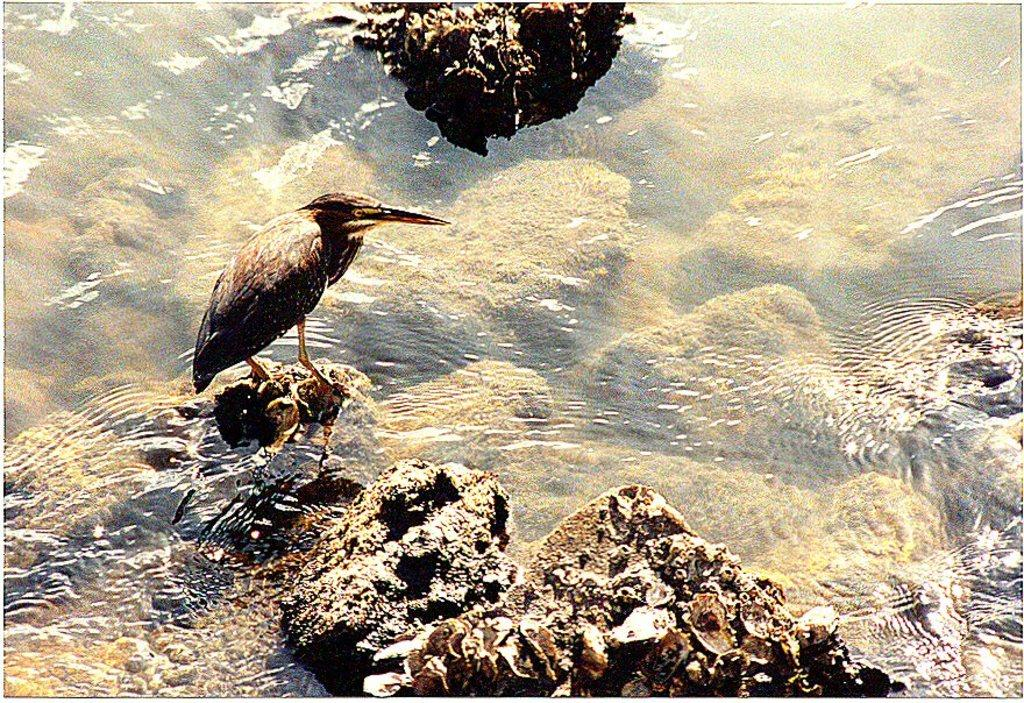What type of animal can be seen in the image? There is a bird in the image. Where is the bird located? The bird is standing on a rock in the image. What else can be seen in the image besides the bird? There is water visible in the image, as well as rocks. What type of rose can be seen growing near the bird in the image? There is no rose present in the image; it features a bird standing on a rock with water and rocks visible. 